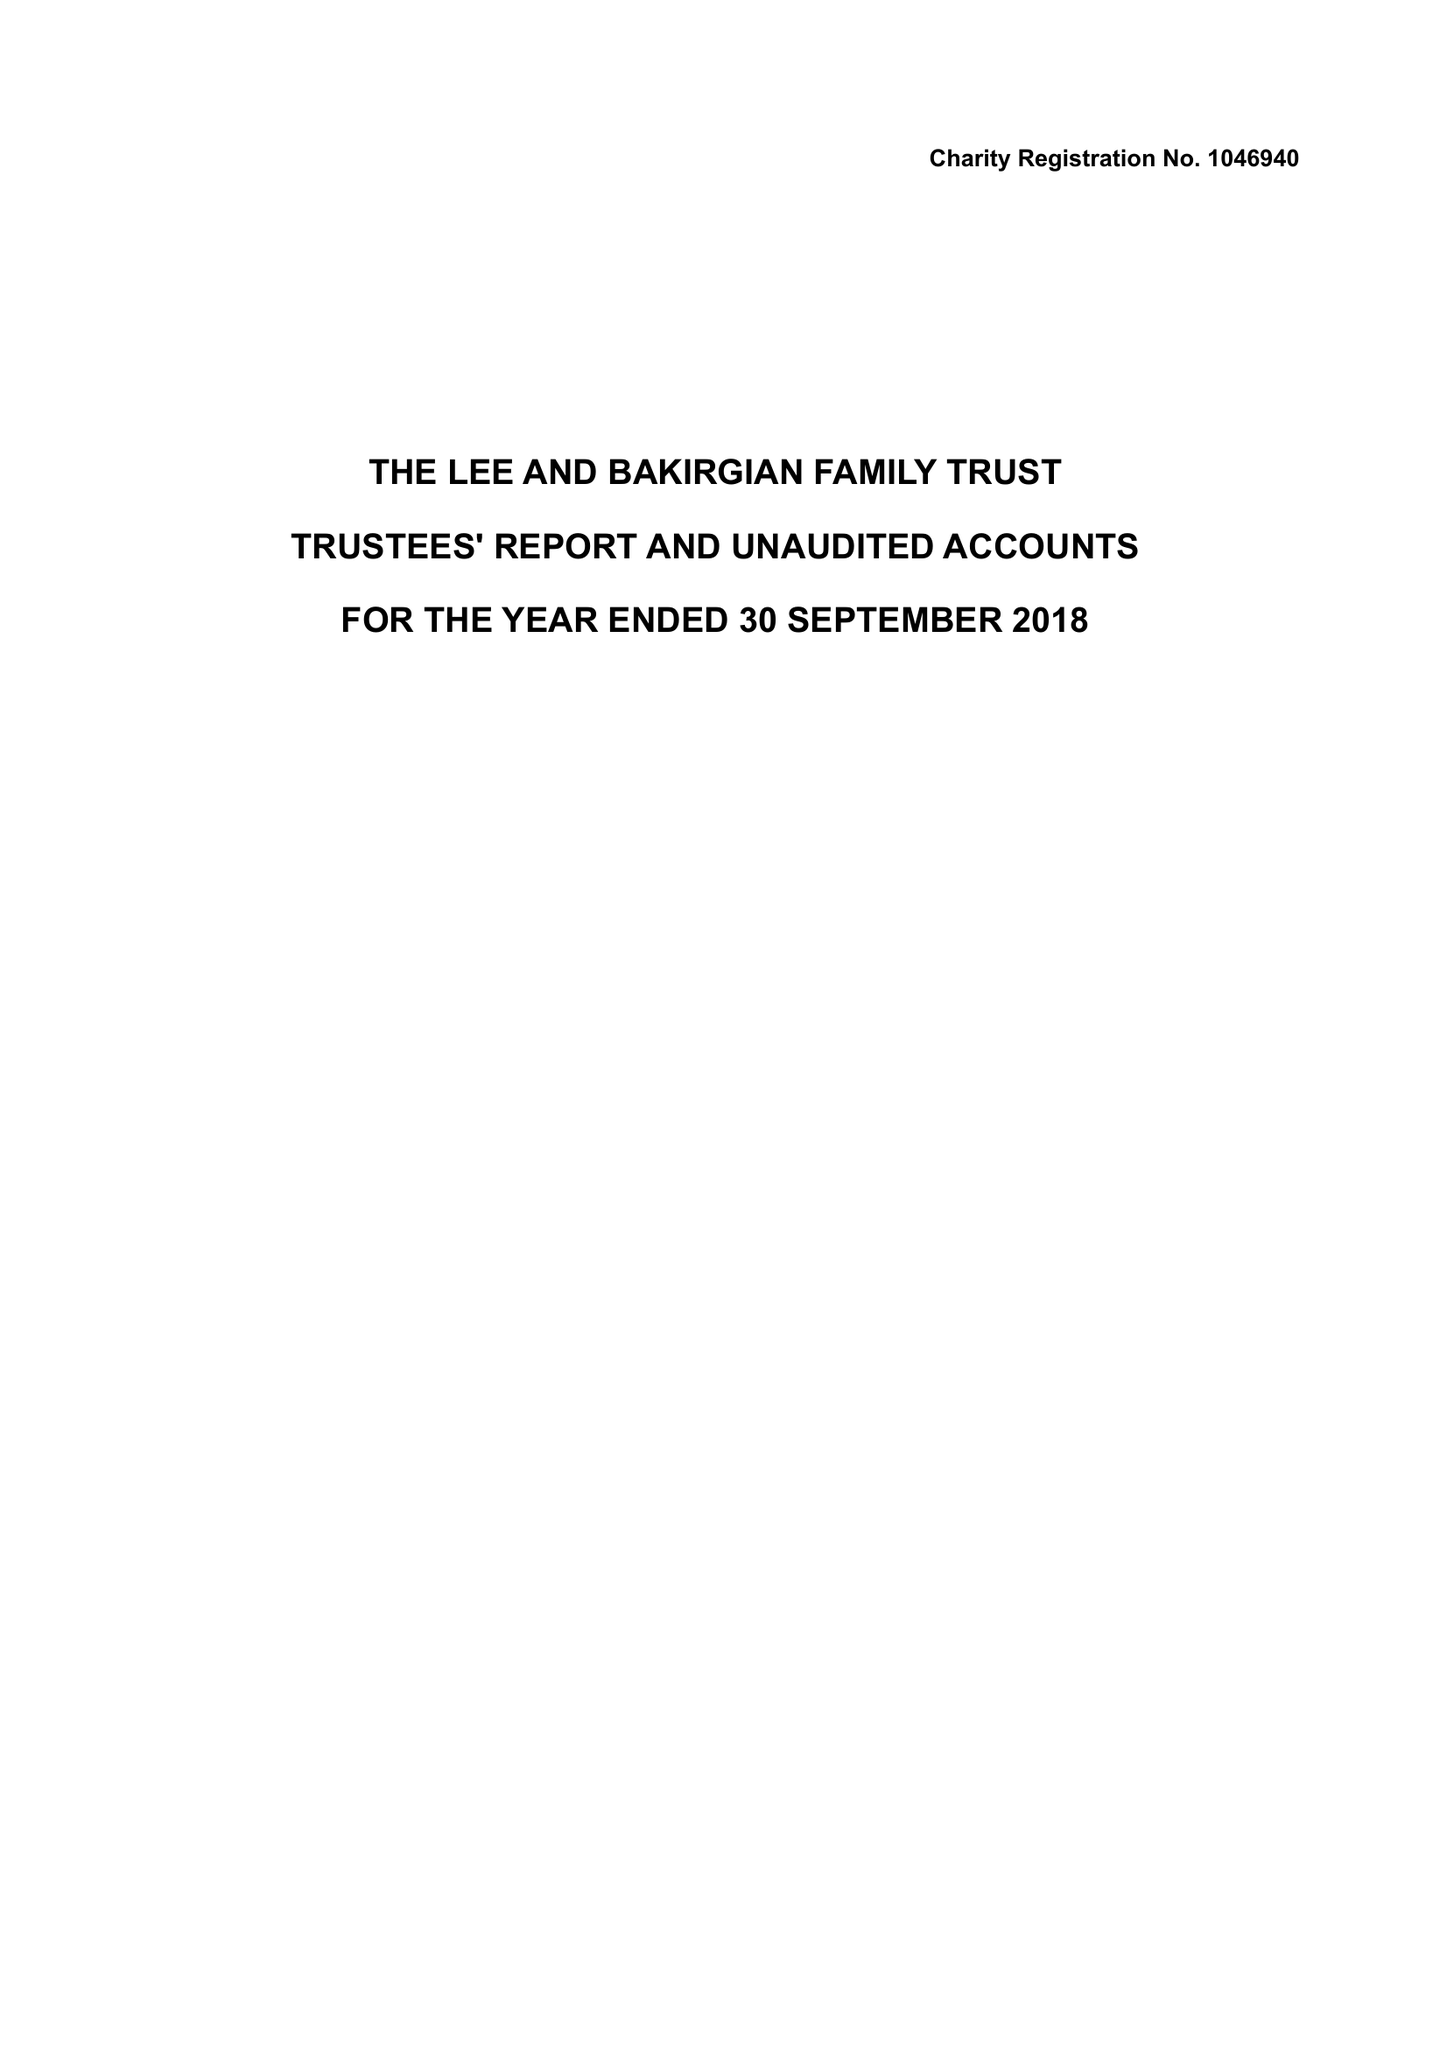What is the value for the spending_annually_in_british_pounds?
Answer the question using a single word or phrase. 32826.00 